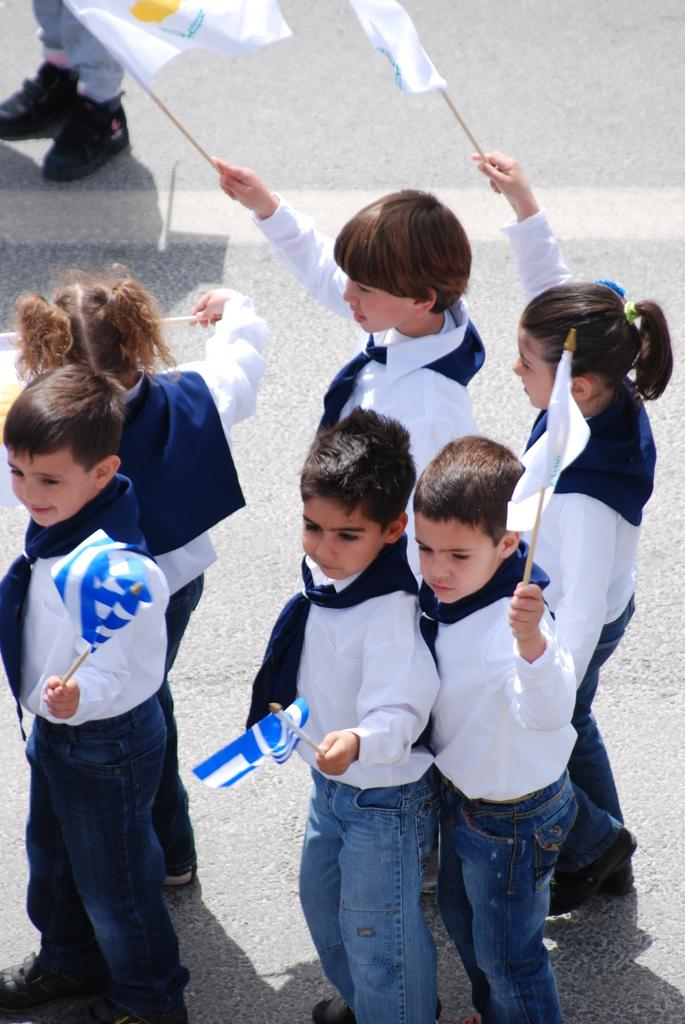What is the main subject of the image? The main subject of the image is a group of children. Can you describe the composition of the group? There are both boys and girls in the image. What can be seen in the background of the image? There is a road visible in the background of the image. What type of bulb is being used to light up the children's faces in the image? There is no bulb present in the image; it is an outdoor scene with natural lighting. What unit of measurement is being used to determine the children's heights in the image? There is no measurement being taken in the image; it is a candid snapshot of the children. 